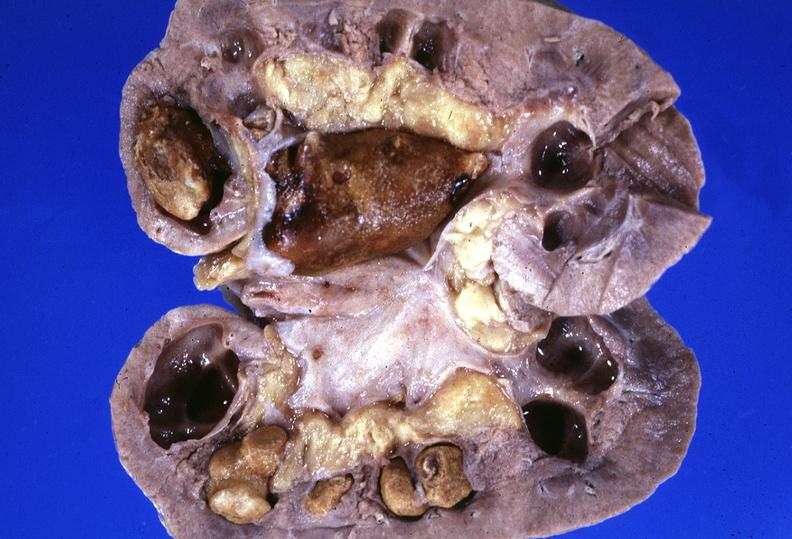does this typical thecoma with yellow foci show kidney, staghorn calculi?
Answer the question using a single word or phrase. No 